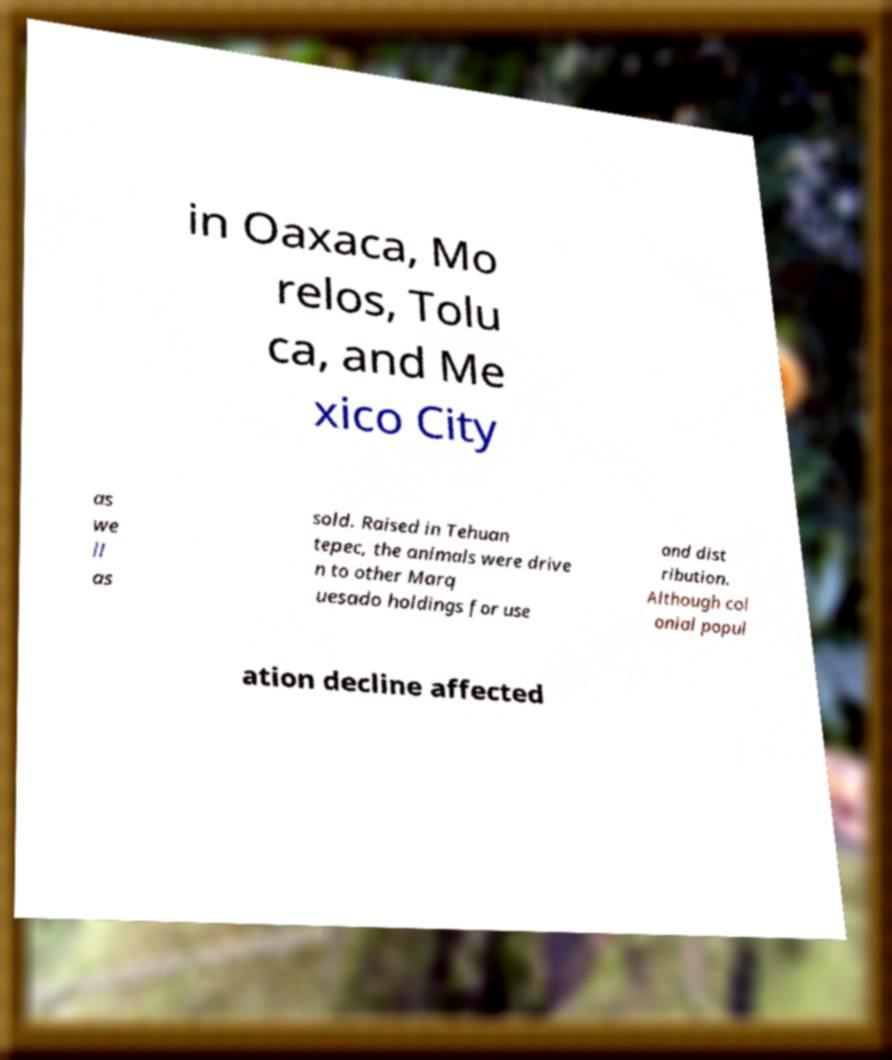Could you assist in decoding the text presented in this image and type it out clearly? in Oaxaca, Mo relos, Tolu ca, and Me xico City as we ll as sold. Raised in Tehuan tepec, the animals were drive n to other Marq uesado holdings for use and dist ribution. Although col onial popul ation decline affected 